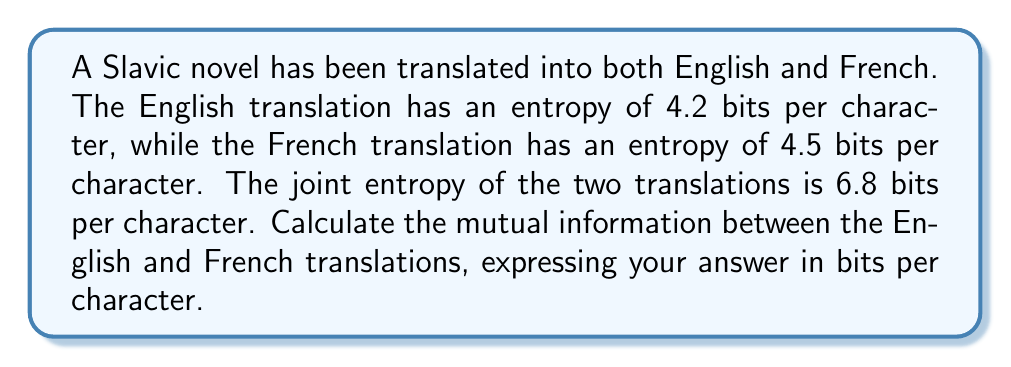Give your solution to this math problem. To solve this problem, we need to understand the concept of mutual information and its relationship with entropy. Mutual information $I(X;Y)$ measures the amount of information shared between two random variables X and Y. In this case, X represents the English translation, and Y represents the French translation.

The formula for mutual information is:

$$I(X;Y) = H(X) + H(Y) - H(X,Y)$$

Where:
$H(X)$ is the entropy of X (English translation)
$H(Y)$ is the entropy of Y (French translation)
$H(X,Y)$ is the joint entropy of X and Y

Given:
$H(X) = 4.2$ bits/character (English)
$H(Y) = 4.5$ bits/character (French)
$H(X,Y) = 6.8$ bits/character (Joint entropy)

Now, let's substitute these values into the formula:

$$I(X;Y) = H(X) + H(Y) - H(X,Y)$$
$$I(X;Y) = 4.2 + 4.5 - 6.8$$
$$I(X;Y) = 8.7 - 6.8$$
$$I(X;Y) = 1.9$$

Therefore, the mutual information between the English and French translations is 1.9 bits per character.

This result indicates the amount of information shared between the two translations, which is likely due to the common source material (the original Slavic novel) and the similarities in conveying the same story and concepts in different languages.
Answer: 1.9 bits per character 